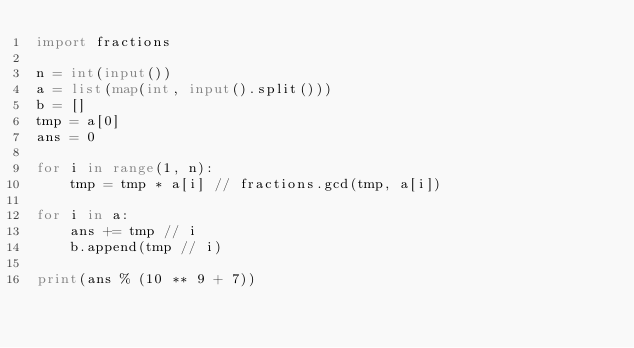<code> <loc_0><loc_0><loc_500><loc_500><_Python_>import fractions

n = int(input())
a = list(map(int, input().split()))
b = []
tmp = a[0]
ans = 0

for i in range(1, n):
    tmp = tmp * a[i] // fractions.gcd(tmp, a[i])

for i in a:
    ans += tmp // i
    b.append(tmp // i)

print(ans % (10 ** 9 + 7))
</code> 